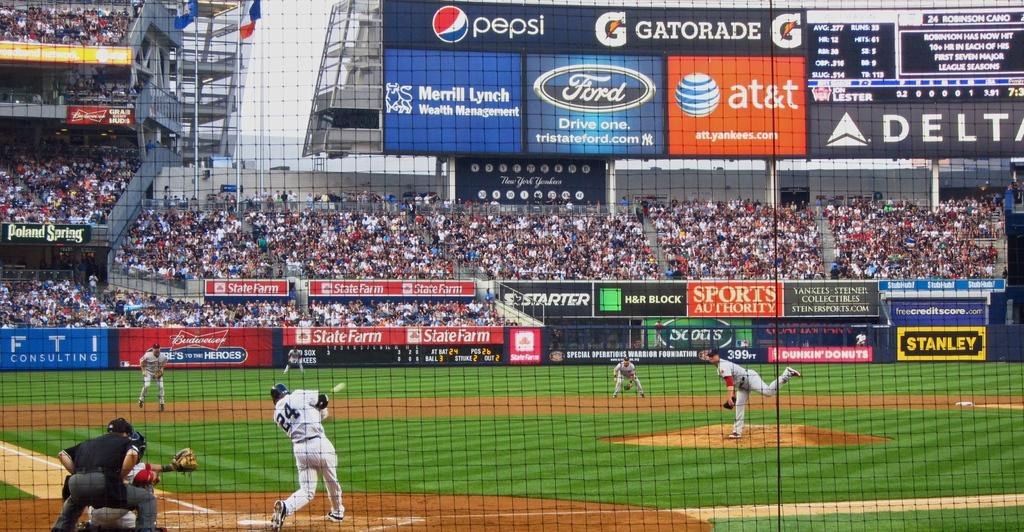<image>
Create a compact narrative representing the image presented. Batter number 24 swings to hit a ball thrown by the pitcher. 